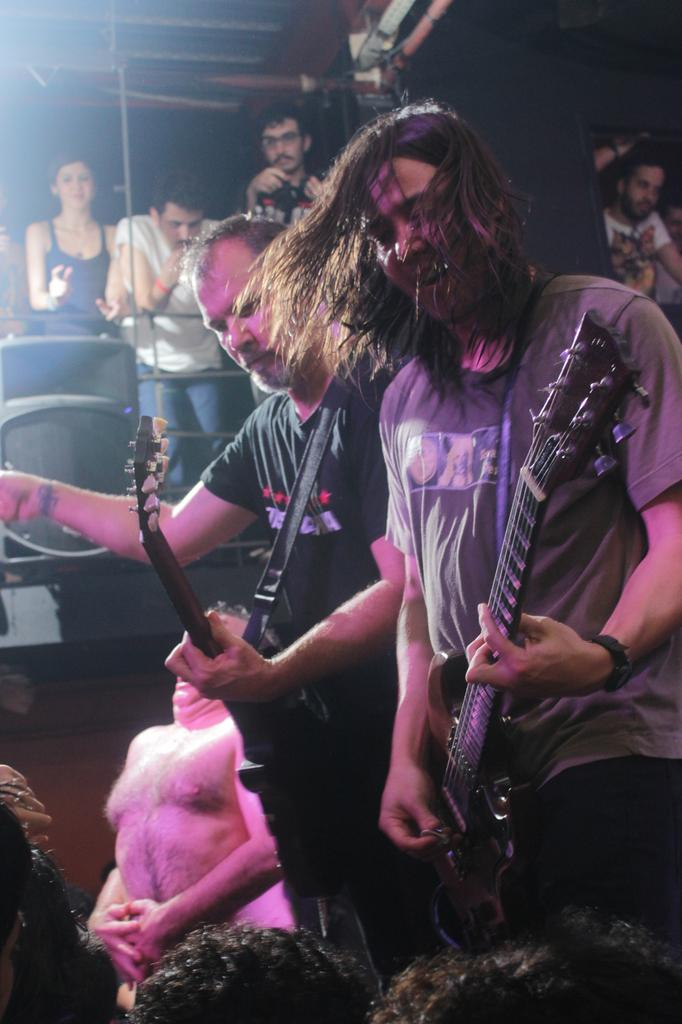What is happening in the image? There is a group of people in the image, and they are playing musical instruments. What are the people doing while playing the instruments? The people are standing while playing the musical instruments. What type of knife is being used to create the thunder sound in the image? There is no knife or thunder sound present in the image; the people are playing musical instruments. 